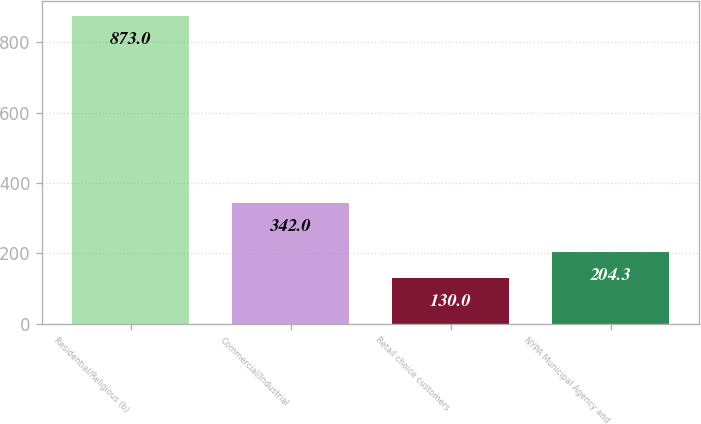<chart> <loc_0><loc_0><loc_500><loc_500><bar_chart><fcel>Residential/Religious (b)<fcel>Commercial/Industrial<fcel>Retail choice customers<fcel>NYPA Municipal Agency and<nl><fcel>873<fcel>342<fcel>130<fcel>204.3<nl></chart> 